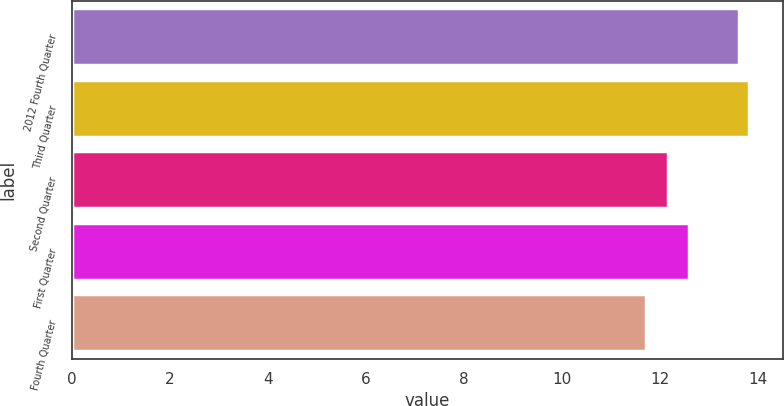<chart> <loc_0><loc_0><loc_500><loc_500><bar_chart><fcel>2012 Fourth Quarter<fcel>Third Quarter<fcel>Second Quarter<fcel>First Quarter<fcel>Fourth Quarter<nl><fcel>13.61<fcel>13.82<fcel>12.16<fcel>12.6<fcel>11.72<nl></chart> 